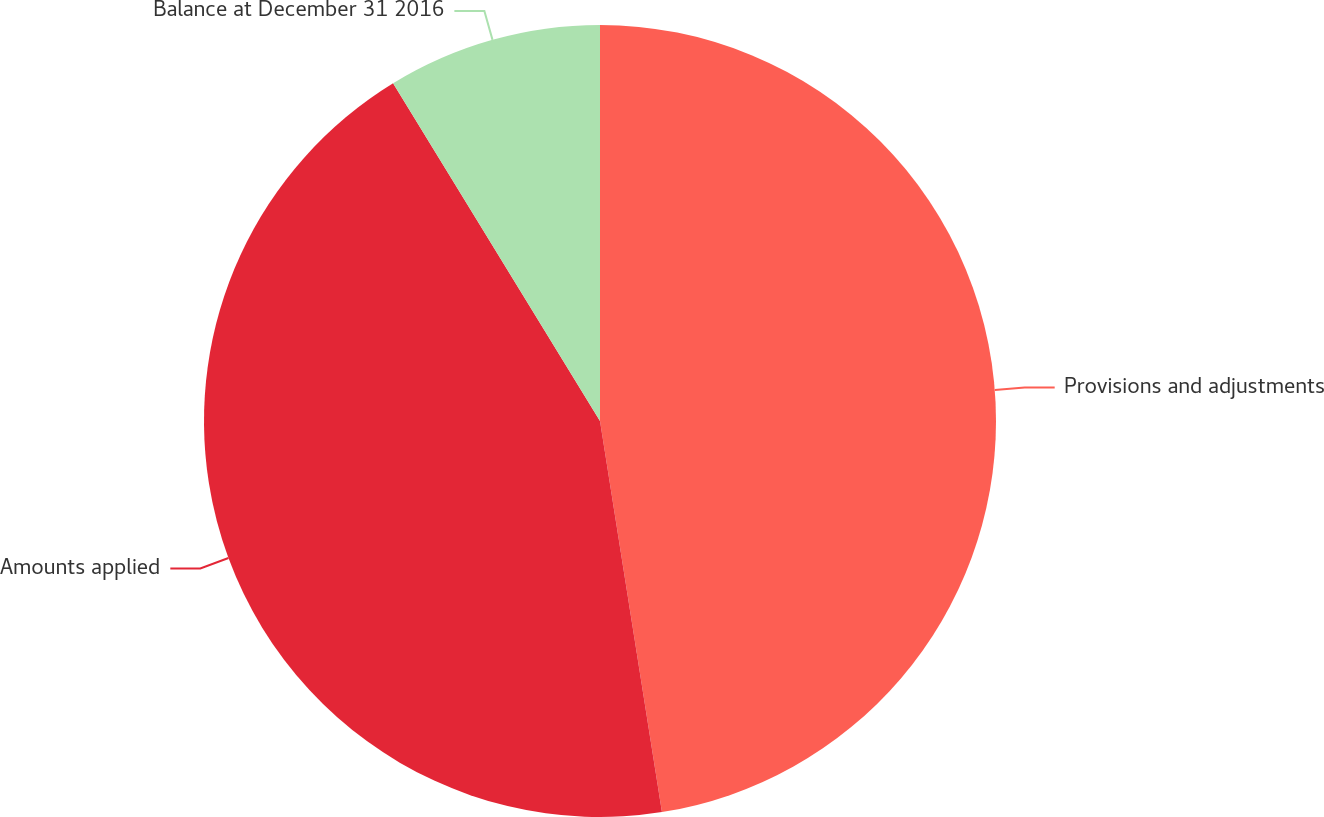<chart> <loc_0><loc_0><loc_500><loc_500><pie_chart><fcel>Provisions and adjustments<fcel>Amounts applied<fcel>Balance at December 31 2016<nl><fcel>47.5%<fcel>43.75%<fcel>8.75%<nl></chart> 